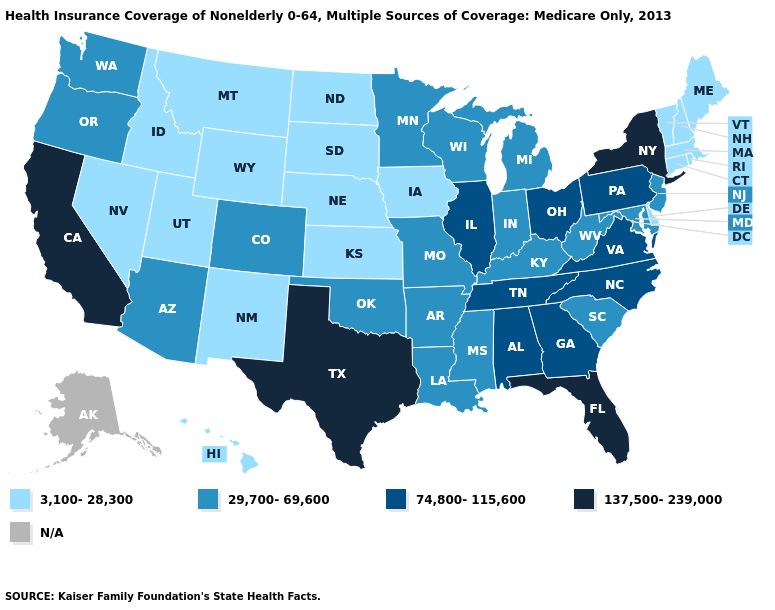What is the value of Georgia?
Give a very brief answer. 74,800-115,600. What is the value of Arizona?
Be succinct. 29,700-69,600. What is the lowest value in the USA?
Concise answer only. 3,100-28,300. Among the states that border Nebraska , does Iowa have the highest value?
Be succinct. No. Which states hav the highest value in the MidWest?
Give a very brief answer. Illinois, Ohio. Does Maine have the highest value in the USA?
Keep it brief. No. What is the value of Pennsylvania?
Give a very brief answer. 74,800-115,600. Name the states that have a value in the range 74,800-115,600?
Be succinct. Alabama, Georgia, Illinois, North Carolina, Ohio, Pennsylvania, Tennessee, Virginia. Name the states that have a value in the range N/A?
Short answer required. Alaska. What is the lowest value in the MidWest?
Write a very short answer. 3,100-28,300. Name the states that have a value in the range 3,100-28,300?
Short answer required. Connecticut, Delaware, Hawaii, Idaho, Iowa, Kansas, Maine, Massachusetts, Montana, Nebraska, Nevada, New Hampshire, New Mexico, North Dakota, Rhode Island, South Dakota, Utah, Vermont, Wyoming. Does Florida have the highest value in the USA?
Write a very short answer. Yes. Does Oregon have the highest value in the West?
Answer briefly. No. Does the first symbol in the legend represent the smallest category?
Write a very short answer. Yes. Does Montana have the lowest value in the USA?
Concise answer only. Yes. 